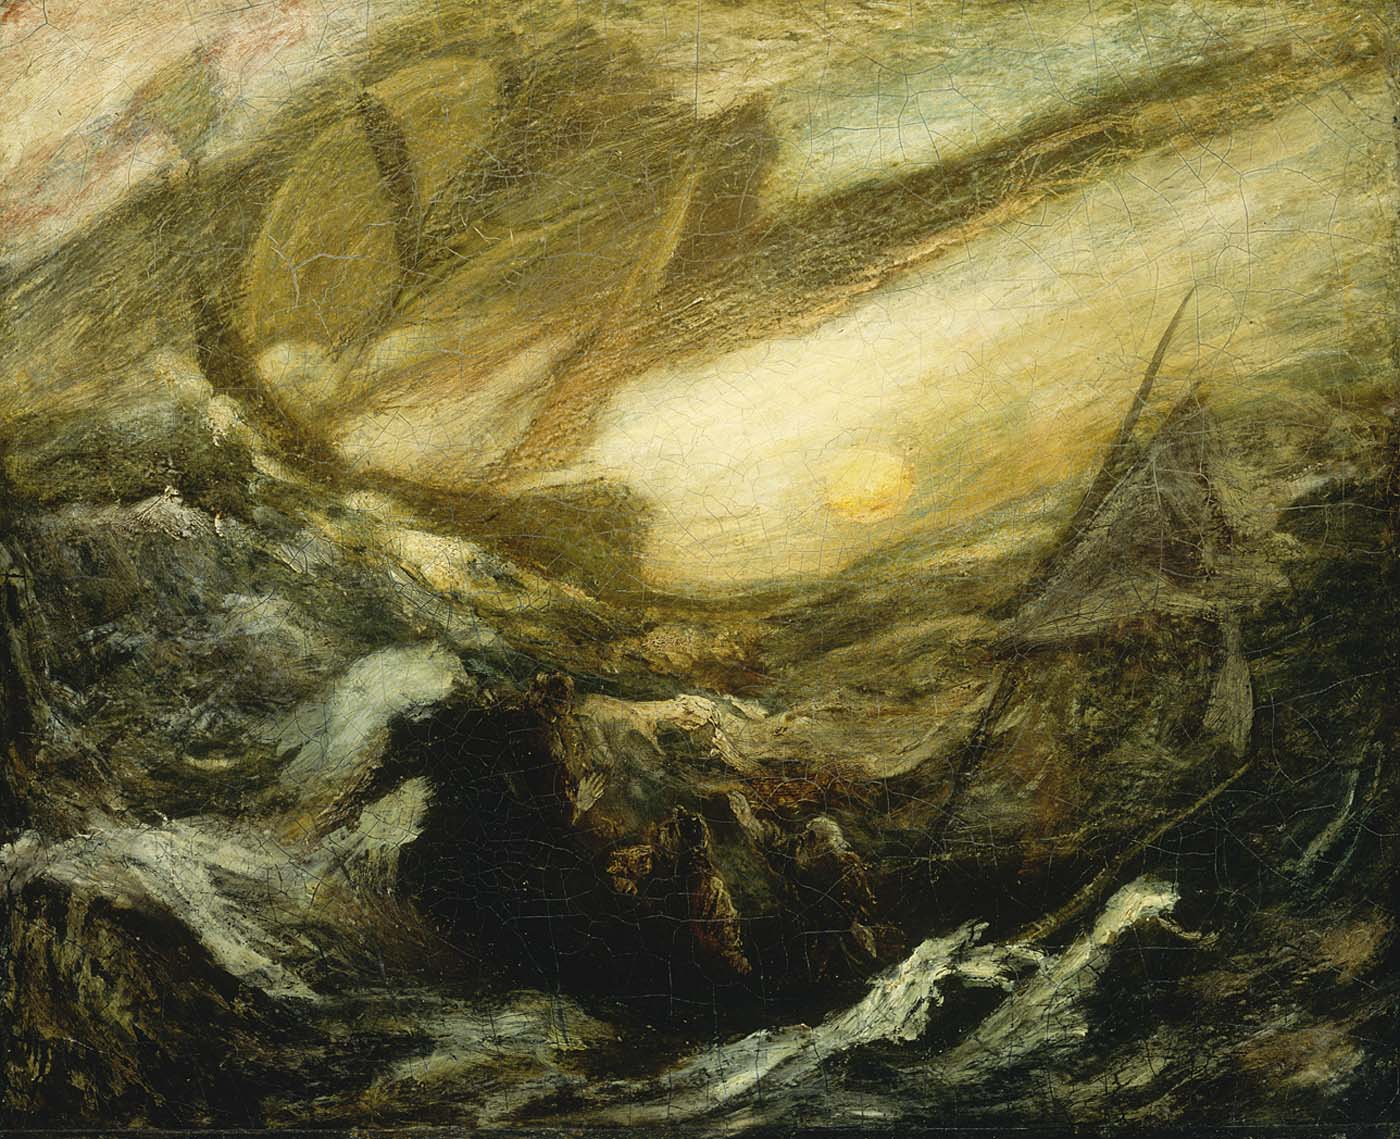What do you think the artist wanted to convey with this painting? The artist likely aimed to convey the raw power and beauty of nature, as well as the impermanence and fragility of human endeavors in the face of natural forces. Through the turbulent sea and dramatic skies, the artist invites us to witness the epic scale and emotional intensity of the scene. There's a poignant contrast between the tumultuous waters and the serene yet powerful presence of the sun, which might reflect the duality of struggle and hope. The painting speaks to the eternal dance between chaos and order, challenge and resilience, despair and optimism. 